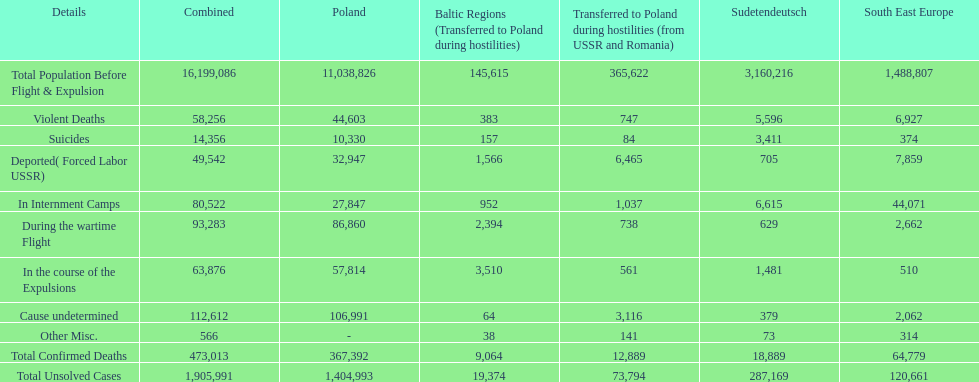Were there more cause undetermined or miscellaneous deaths in the baltic states? Cause undetermined. 